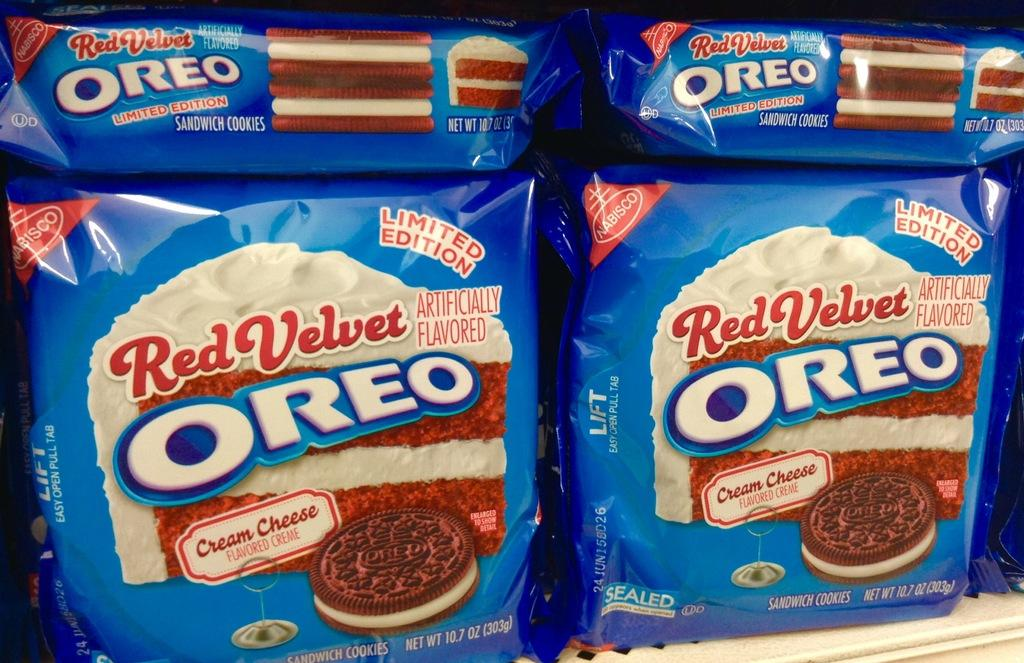What is the main subject of the image? The main subject of the image is four Oreo cookie packs. Where are the Oreo cookie packs located in the image? The Oreo cookie packs are on a white surface in the foreground of the image. What type of goat can be seen writing on the station in the image? There is no goat or station present in the image; it only features four Oreo cookie packs on a white surface. 